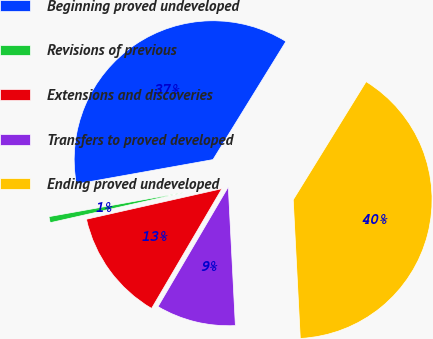<chart> <loc_0><loc_0><loc_500><loc_500><pie_chart><fcel>Beginning proved undeveloped<fcel>Revisions of previous<fcel>Extensions and discoveries<fcel>Transfers to proved developed<fcel>Ending proved undeveloped<nl><fcel>36.62%<fcel>0.71%<fcel>13.02%<fcel>9.26%<fcel>40.39%<nl></chart> 